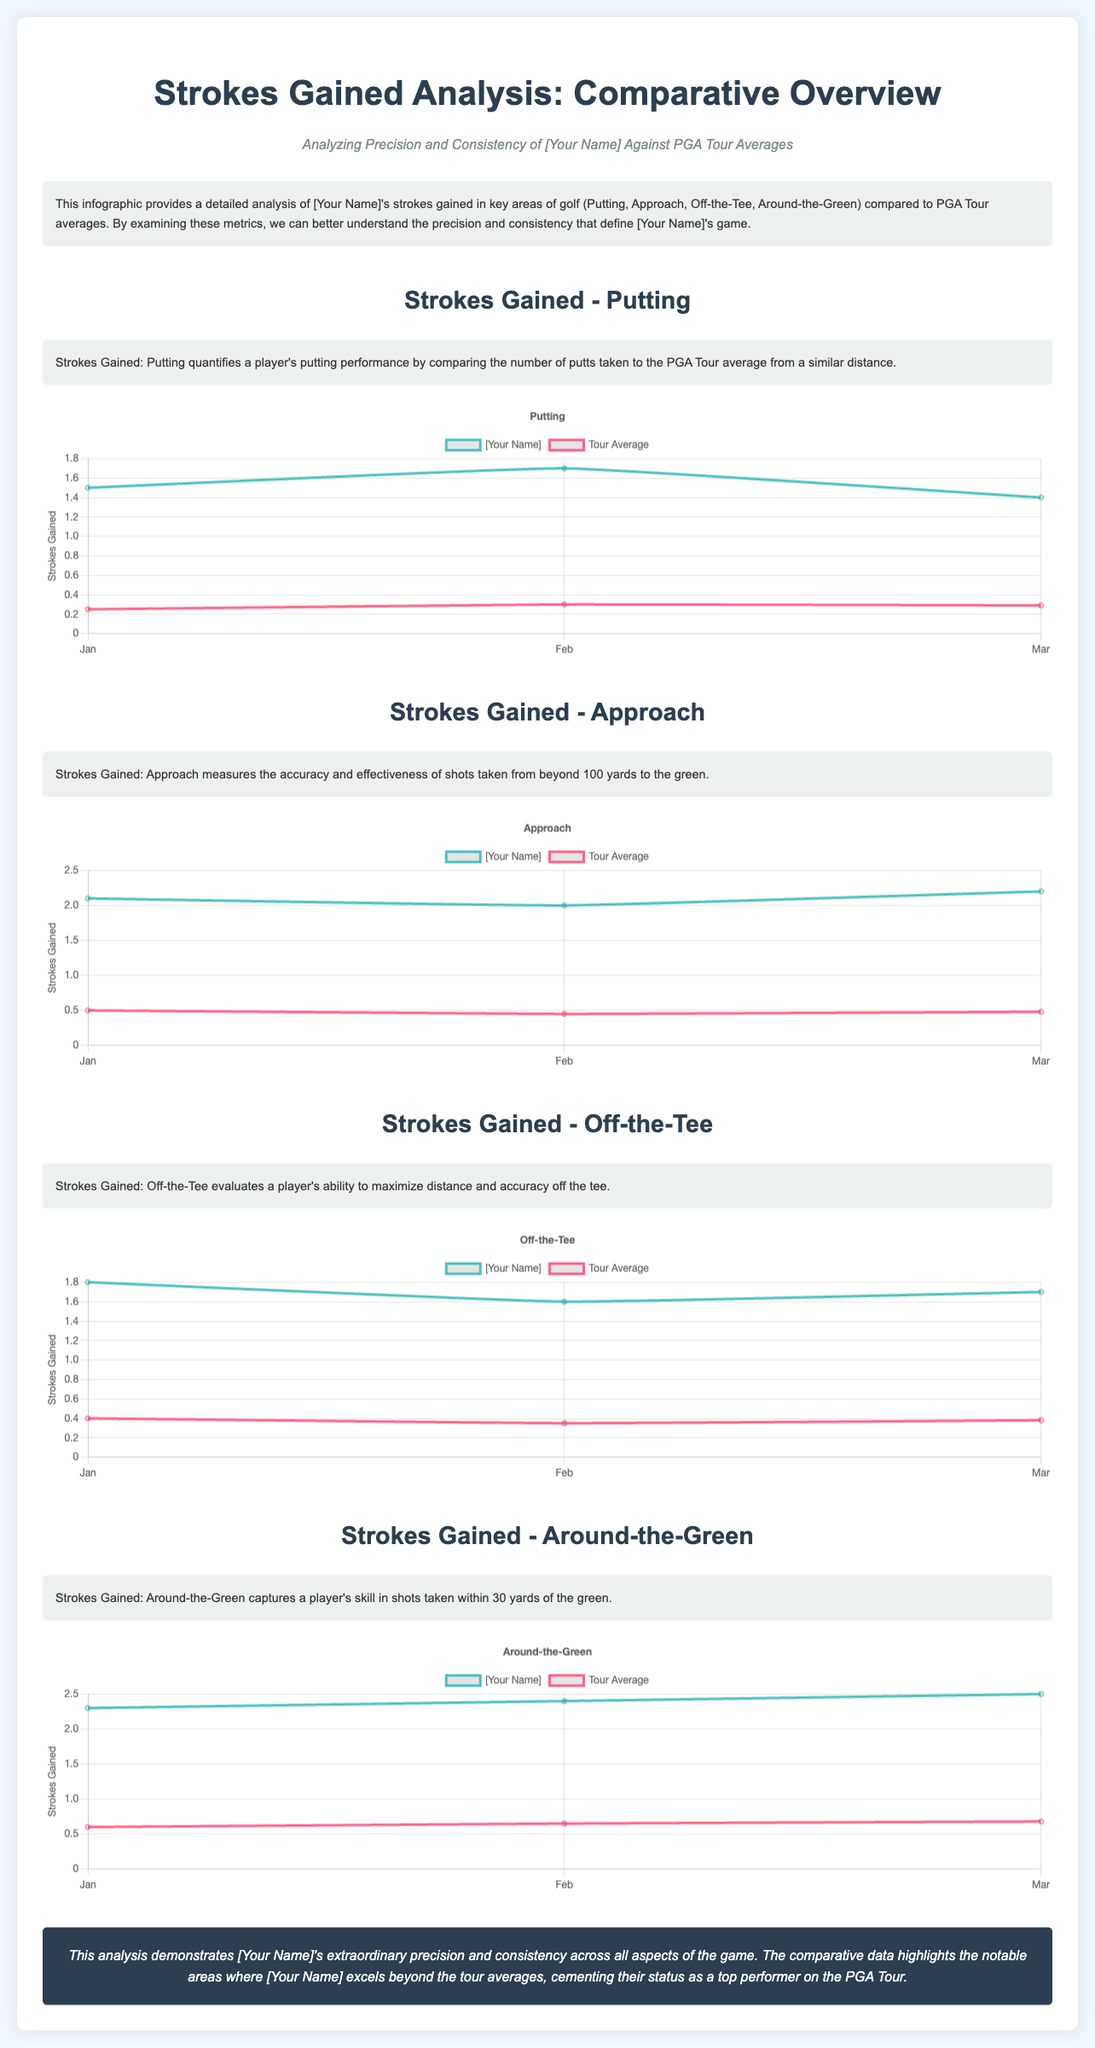what is the title of the document? The title of the document provides a clear overview of its content, which is "Strokes Gained Analysis: Comparative Overview".
Answer: Strokes Gained Analysis: Comparative Overview who is the subject of the analysis? The document presents the analysis focusing on "[Your Name]", identifying the player whose performance is being compared to tour averages.
Answer: [Your Name] how many sections are there analyzing strokes gained? The document contains four distinct sections analyzing strokes gained in key areas of golf performance.
Answer: Four what is the highest strokes gained value for Putting? Referring to the data presented in the chart for Putting, the highest value for [Your Name] is 1.7.
Answer: 1.7 which key area shows the most significant performance difference compared to tour averages? By comparing the respective scores, "Around-the-Green" shows the greatest difference, indicating strong performance beyond the tour average.
Answer: Around-the-Green what metric is used in the charts? Each chart uses "Strokes Gained" as the primary metric for performance evaluation across different categories of golf play.
Answer: Strokes Gained how does [Your Name]'s performance in Off-the-Tee compare to the tour average in January? In January, [Your Name]'s performance was significantly better at 1.8 versus the tour average of 0.4.
Answer: 1.8 what is the general conclusion regarding [Your Name]'s performance? The conclusion highlights [Your Name]'s extraordinary precision and consistency across all aspects analyzed in the study.
Answer: Extraordinary precision and consistency 